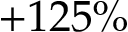<formula> <loc_0><loc_0><loc_500><loc_500>+ 1 2 5 \%</formula> 